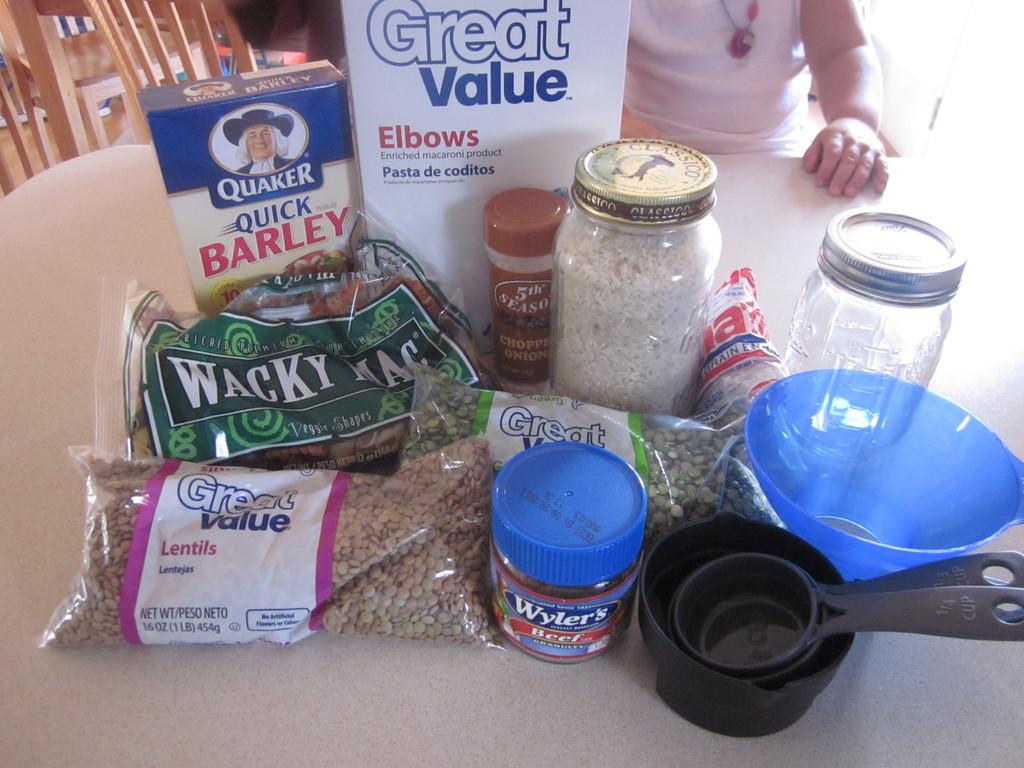What is the brand of the quick barley?
Your response must be concise. Quaker. What type of pasta is that?
Your response must be concise. Great value elbows. 